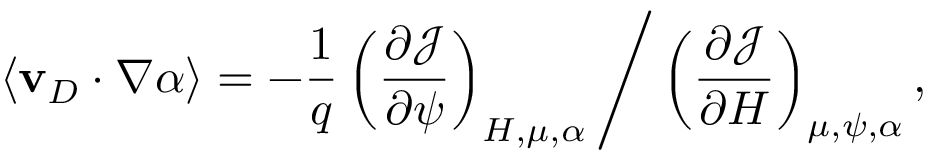<formula> <loc_0><loc_0><loc_500><loc_500>\langle v _ { D } \cdot \nabla \alpha \rangle = - \frac { 1 } { q } \left ( \frac { \partial \mathcal { J } } { \partial \psi } \right ) _ { H , \mu , \alpha } \Big / \left ( \frac { \partial \mathcal { J } } { \partial H } \right ) _ { \mu , \psi , \alpha } ,</formula> 